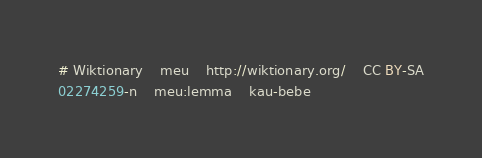<code> <loc_0><loc_0><loc_500><loc_500><_SQL_># Wiktionary	meu	http://wiktionary.org/	CC BY-SA
02274259-n	meu:lemma	kau-bebe
</code> 